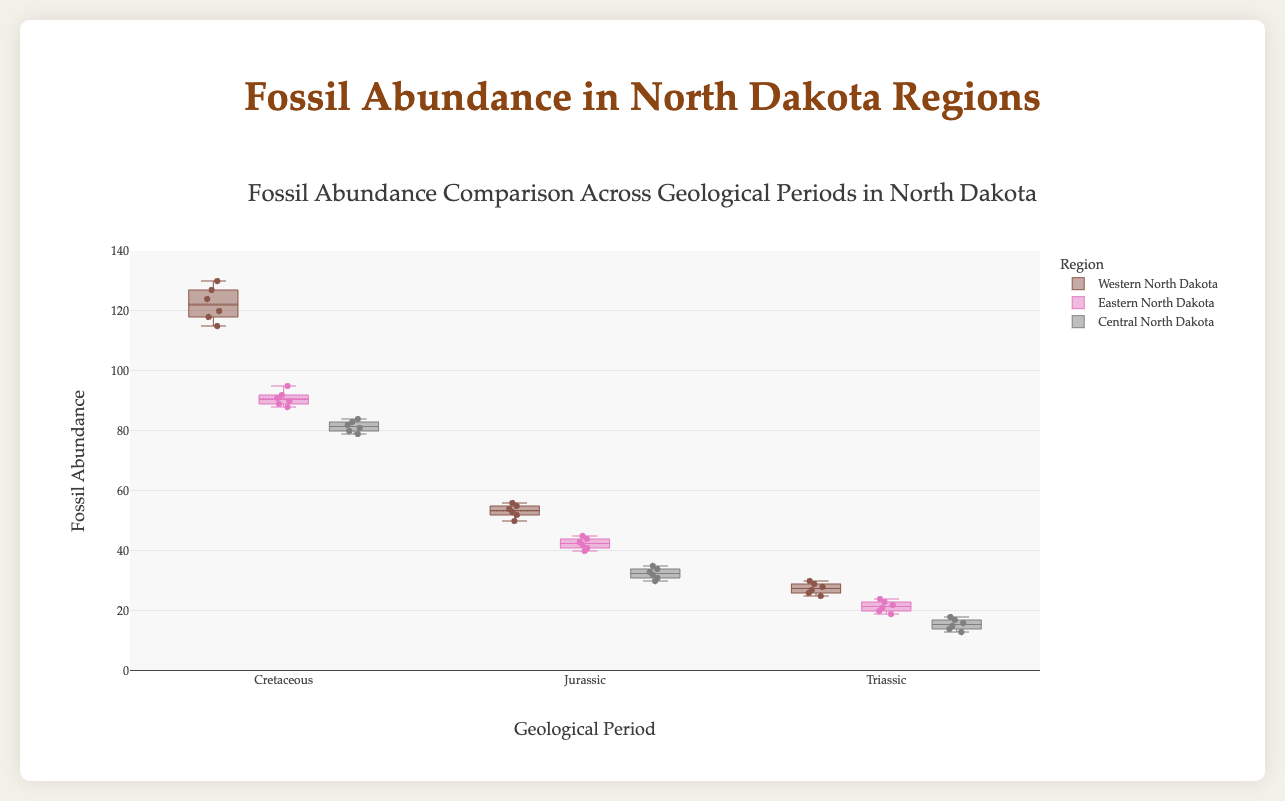Which region has the highest fossil abundance during the Cretaceous period? By looking at the box plot for the Cretaceous period, we compare the topmost Whiskers of all the box plots for the regions. Western North Dakota has the highest upper range value.
Answer: Western North Dakota Which region shows the lowest median fossil abundance in the Jurassic period? Examine the median line (the line inside the box) for each region during the Jurassic period. The median fossil count for Central North Dakota is the lowest.
Answer: Central North Dakota What is the range of fossil abundance for Eastern North Dakota in the Triassic period? The range is calculated by subtracting the lowest value (bottom whisker) from the highest value (top whisker) in the Eastern North Dakota for the Triassic Period. Range = 24 - 19.
Answer: 5 How does the median fossil abundance of Western North Dakota change from the Triassic to the Cretaceous period? Find the median values (central line within each box) for Western North Dakota in both periods and calculate the difference. Increase from around 27 to around 122.
Answer: Increases by approximately 95 Which geological period shows the most consistent fossil abundance for Central North Dakota? Consistency can be inferred from the size of the box; a smaller box indicates less spread and more consistency. The Cretaceous period has the smallest box.
Answer: Cretaceous Compare the third quartile fossil abundance of Eastern North Dakota in the Cretaceous and Jurassic periods. The third quartile (top of the box) in the Cretaceous period is higher than in the Jurassic period. The analysis shows a shift from around 91 to around 44-45.
Answer: Higher in Cretaceous Which period has the greatest overall variation in fossil abundance for Western North Dakota? Variation is depicted by the length from the lowest to the highest whisker. The Cretaceous period has the longest whiskers indicating the greatest variation.
Answer: Cretaceous What is the interquartile range (IQR) of fossil abundance for Central North Dakota during the Triassic period? Calculate the IQR by subtracting the first quartile (bottom of the box) from the third quartile (top of the box) for Central North Dakota in the Triassic Period. IQR = 17 - 14.
Answer: 3 Among all regions, which one has shown the maximum decrease in fossil abundance from the Cretaceous to the Jurassic period? Determine the central tendency for each region in both periods. The Western region shows a notable decrease in the median from Cretaceous (124) to Jurassic (54).
Answer: Western North Dakota Which geological period demonstrates the lowest overall fossil abundance across all regions? Observe the central tendency and range of each box plot for all periods. The Triassic period exhibits the lowest values throughout all regions.
Answer: Triassic 